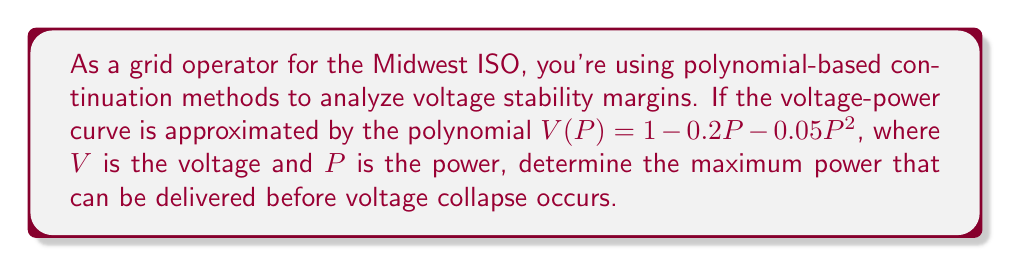Solve this math problem. To find the maximum power before voltage collapse, we need to follow these steps:

1) The voltage collapse point occurs at the nose of the V-P curve, which is the point where $\frac{dV}{dP} = 0$.

2) Let's differentiate $V(P)$ with respect to $P$:

   $$\frac{dV}{dP} = -0.2 - 0.1P$$

3) Set this equal to zero and solve for $P$:

   $$-0.2 - 0.1P = 0$$
   $$-0.1P = 0.2$$
   $$P = -2$$

4) The negative value doesn't make physical sense in this context, so we need to find the maximum of the original function in the positive domain.

5) We can do this by finding the vertex of the parabola. For a quadratic function $ax^2 + bx + c$, the x-coordinate of the vertex is given by $-\frac{b}{2a}$.

6) In our case, $a = -0.05$, $b = -0.2$, so:

   $$P_{max} = -\frac{-0.2}{2(-0.05)} = 2$$

7) We can verify this by plugging in values slightly less than and greater than 2 into the original equation to confirm that $P = 2$ gives the lowest voltage.
Answer: $P_{max} = 2$ 